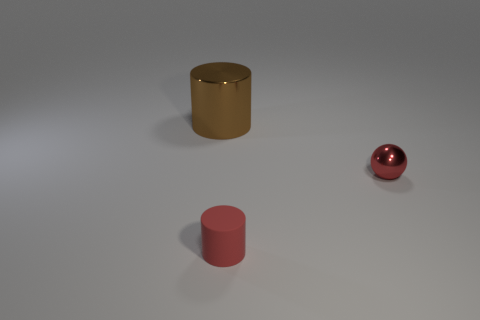Add 3 small cyan cylinders. How many objects exist? 6 Subtract all cylinders. How many objects are left? 1 Add 1 balls. How many balls are left? 2 Add 1 small purple matte blocks. How many small purple matte blocks exist? 1 Subtract 0 blue cylinders. How many objects are left? 3 Subtract all big brown objects. Subtract all yellow metallic cubes. How many objects are left? 2 